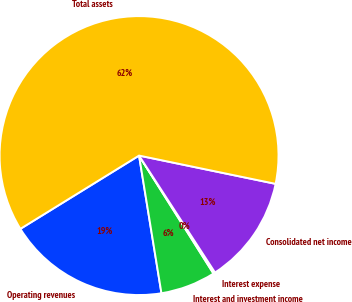<chart> <loc_0><loc_0><loc_500><loc_500><pie_chart><fcel>Operating revenues<fcel>Interest and investment income<fcel>Interest expense<fcel>Consolidated net income<fcel>Total assets<nl><fcel>18.76%<fcel>6.39%<fcel>0.21%<fcel>12.58%<fcel>62.05%<nl></chart> 